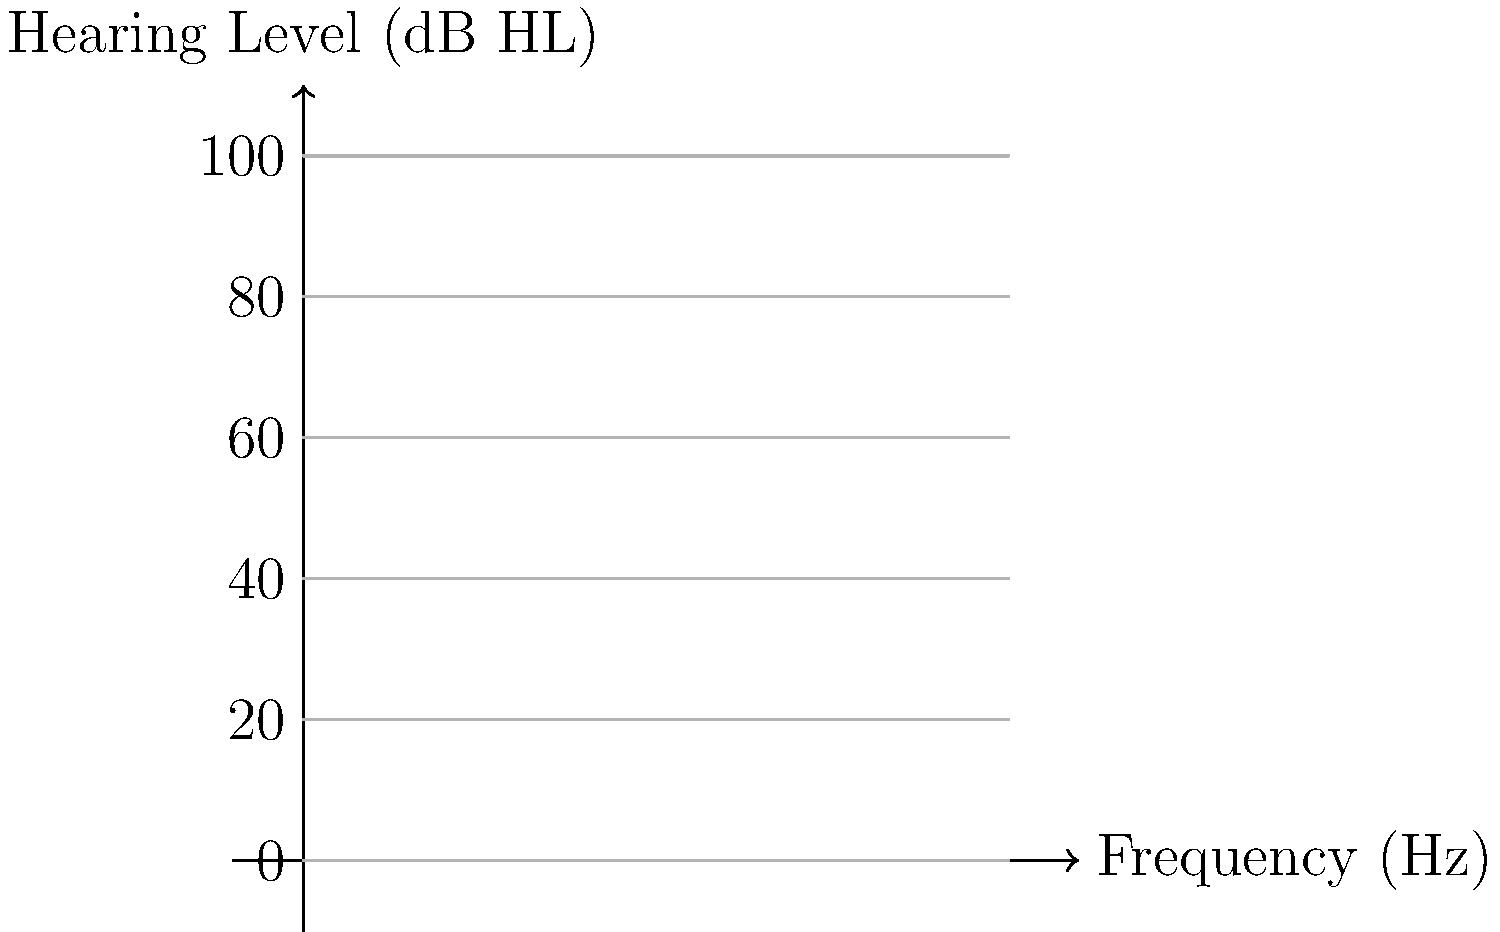Based on the audiogram provided, which ear has better hearing thresholds at 4000 Hz, and what is the difference in hearing level between the two ears at this frequency? To answer this question, we need to follow these steps:

1. Locate 4000 Hz (4k) on the frequency axis (x-axis) of the audiogram.
2. Find the hearing thresholds for both ears at 4000 Hz:
   - Follow the 4k vertical line up to where it intersects with each ear's line.
   - The blue line represents the left ear.
   - The red line represents the right ear.
3. Read the hearing level (y-axis) for each ear at 4000 Hz:
   - Left ear (blue): approximately 70 dB HL
   - Right ear (red): approximately 60 dB HL
4. Compare the two values:
   - Lower dB HL values indicate better hearing.
   - The right ear has a lower value, so it has better hearing at 4000 Hz.
5. Calculate the difference:
   - Difference = Left ear threshold - Right ear threshold
   - Difference = 70 dB HL - 60 dB HL = 10 dB HL

Therefore, the right ear has better hearing thresholds at 4000 Hz, and the difference in hearing level between the two ears at this frequency is 10 dB HL.
Answer: Right ear; 10 dB HL difference 